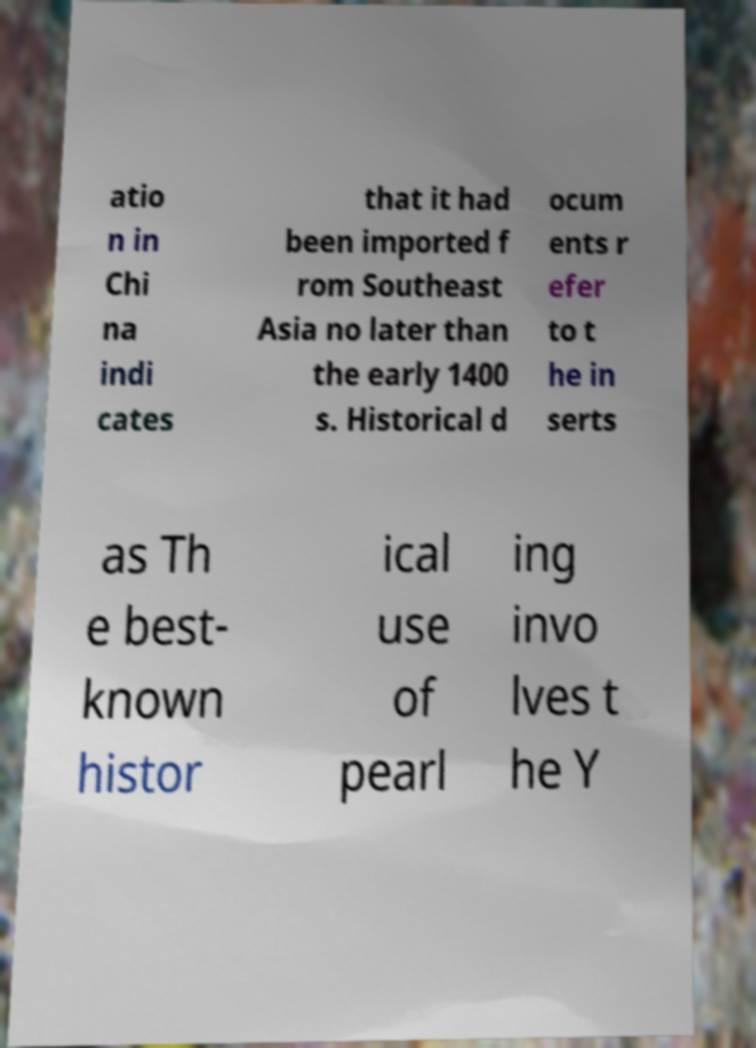Please read and relay the text visible in this image. What does it say? atio n in Chi na indi cates that it had been imported f rom Southeast Asia no later than the early 1400 s. Historical d ocum ents r efer to t he in serts as Th e best- known histor ical use of pearl ing invo lves t he Y 